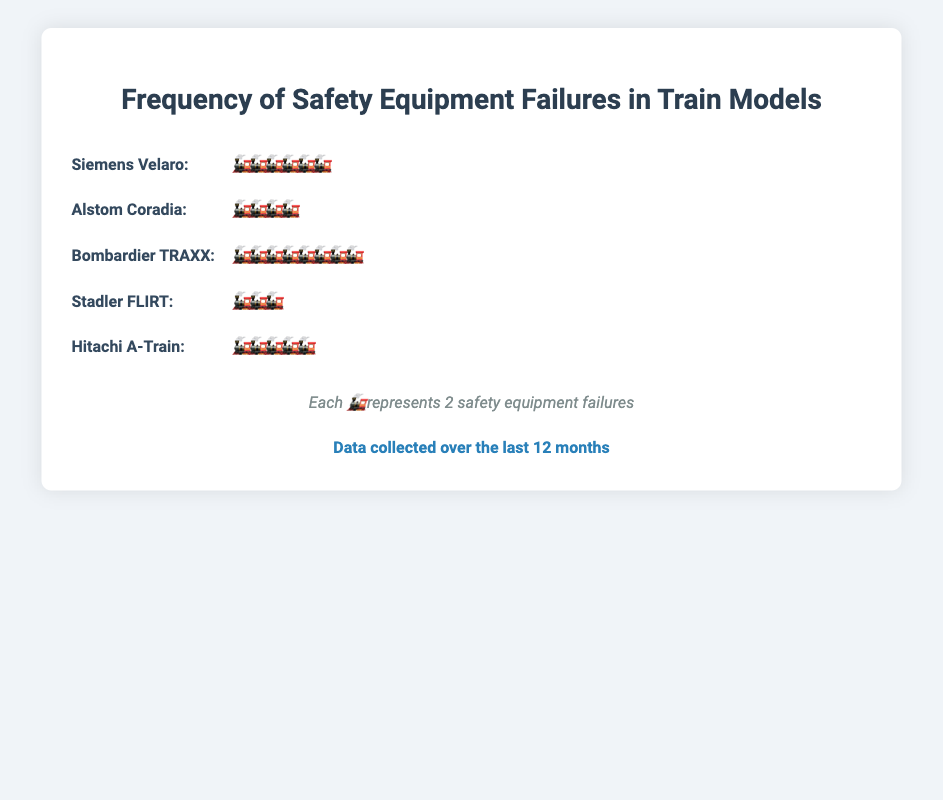What is the title of the figure? The title is usually located at the top of the figure, indicating the main subject of the plot.
Answer: Frequency of Safety Equipment Failures in Train Models Which train model has the most safety equipment failures? Look at the row that has the most icons representing failures.
Answer: Bombardier TRAXX How many safety equipment failures did the Siemens Velaro experience? Count the number of icons (each representing 2 failures) in the Siemens Velaro row and multiply by 2.
Answer: 12 What time period does the data cover? This information is provided at the bottom of the figure under "Data collected over...".
Answer: Last 12 months Which train model has the least safety equipment failures? Identify the row with the fewest number of icons representing failures.
Answer: Stadler FLIRT How many total safety equipment failures are recorded for all train models combined? Sum the number of icons for all models and multiply by 2. Stadler FLIRT: 3 icons (6), Alstom Coradia: 4 icons (8), Siemens Velaro: 6 icons (12), Hitachi A-Train: 5 icons (10), Bombardier TRAXX: 8 icons (16). Therefore, 6+8+12+10+16 = 52.
Answer: 52 Which train models have more than 10 safety equipment failures? Identify the rows with more than 5 icons (representing over 10 failures each).
Answer: Siemens Velaro, Bombardier TRAXX, Hitachi A-Train What is the average number of safety equipment failures per train model? Sum the total number of failures and divide by the number of train models. Total failures: 52, Number of models: 5. Therefore, 52/5 = 10.4.
Answer: 10.4 Compare the safety equipment failures between Siemens Velaro and Hitachi A-Train. Siemens Velaro has 12 failures (6 icons), and Hitachi A-Train has 10 failures (5 icons).
Answer: Siemens Velaro has 2 more failures Which train model has exactly 8 safety equipment failures, and how is it visually represented? Look for the model with 4 icons, as each icon represents 2 failures (2*4=8).
Answer: Alstom Coradia, represented by 4 icons 